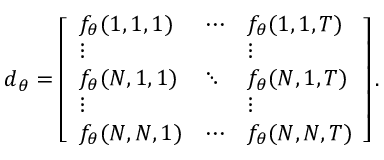<formula> <loc_0><loc_0><loc_500><loc_500>d _ { \theta } = \left [ \begin{array} { l l l } { f _ { \theta } ( 1 , 1 , 1 ) } & { \cdots } & { f _ { \theta } ( 1 , 1 , T ) } \\ { \vdots } & & { \vdots } \\ { f _ { \theta } ( N , 1 , 1 ) } & { \ddots } & { f _ { \theta } ( N , 1 , T ) } \\ { \vdots } & & { \vdots } \\ { f _ { \theta } ( N , N , 1 ) } & { \cdots } & { f _ { \theta } ( N , N , T ) } \end{array} \right ] .</formula> 